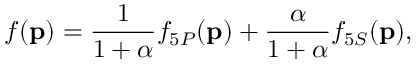Convert formula to latex. <formula><loc_0><loc_0><loc_500><loc_500>f ( { p } ) = \frac { 1 } { 1 + \alpha } f _ { 5 P } ( { p } ) + \frac { \alpha } { 1 + \alpha } f _ { 5 S } ( { p } ) ,</formula> 